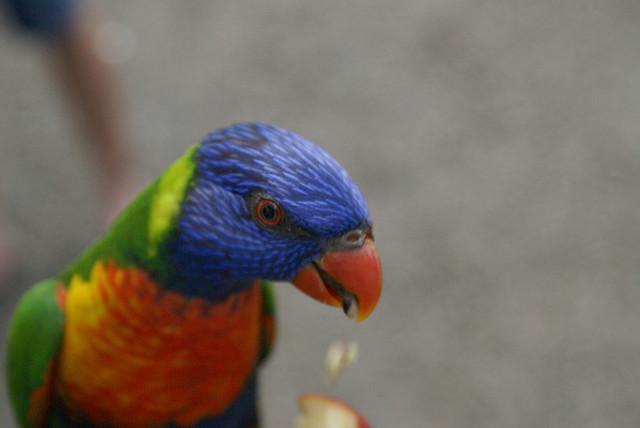Who is holding the cup?
Be succinct. No one. What animal is this?
Keep it brief. Parrot. What color is in the background of this photo?
Be succinct. Gray. What color is most dominant on this bird?
Concise answer only. Orange. How many bird are in the photo?
Short answer required. 1. 